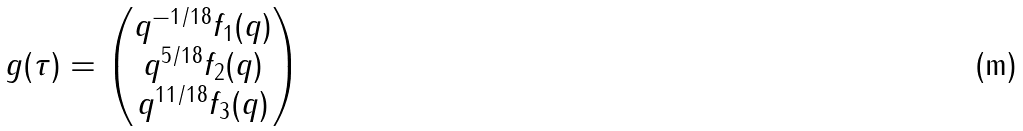Convert formula to latex. <formula><loc_0><loc_0><loc_500><loc_500>g ( \tau ) = \begin{pmatrix} q ^ { - 1 / 1 8 } f _ { 1 } ( q ) \\ q ^ { 5 / 1 8 } f _ { 2 } ( q ) \\ q ^ { 1 1 / 1 8 } f _ { 3 } ( q ) \\ \end{pmatrix}</formula> 